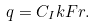Convert formula to latex. <formula><loc_0><loc_0><loc_500><loc_500>q = C _ { I } k F r .</formula> 